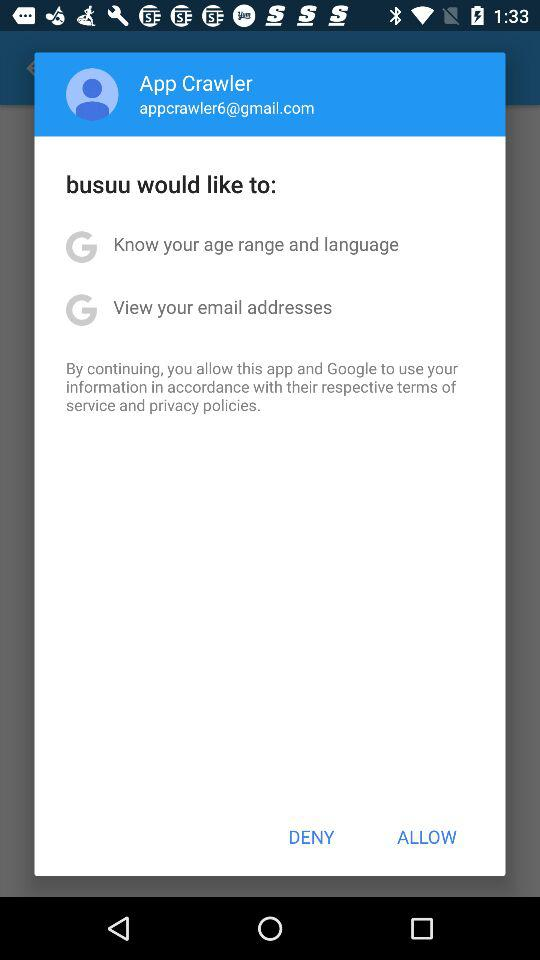What application would like to know my age range and language?
Answer the question using a single word or phrase. It is "busuu". 